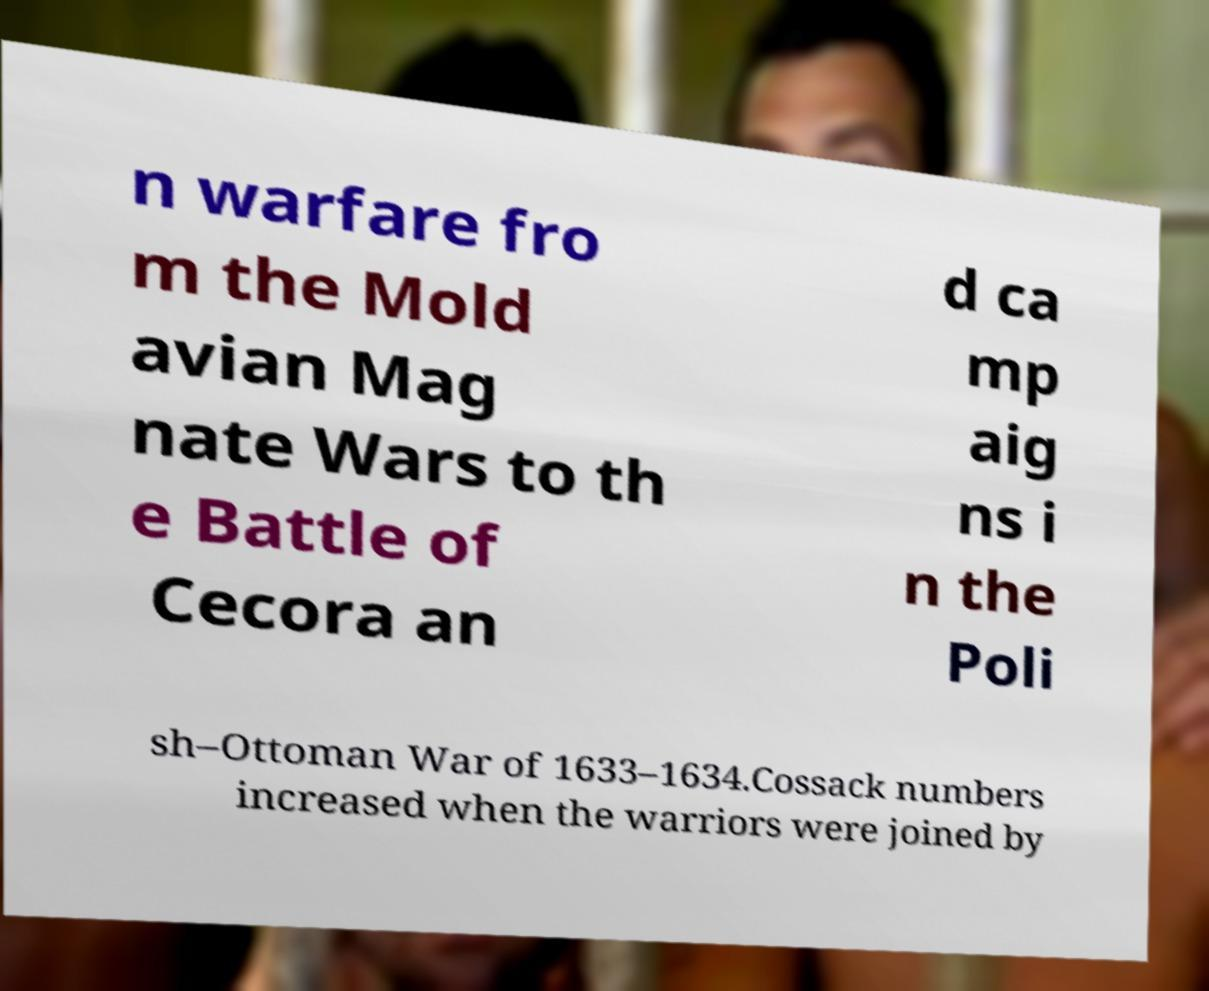Please identify and transcribe the text found in this image. n warfare fro m the Mold avian Mag nate Wars to th e Battle of Cecora an d ca mp aig ns i n the Poli sh–Ottoman War of 1633–1634.Cossack numbers increased when the warriors were joined by 